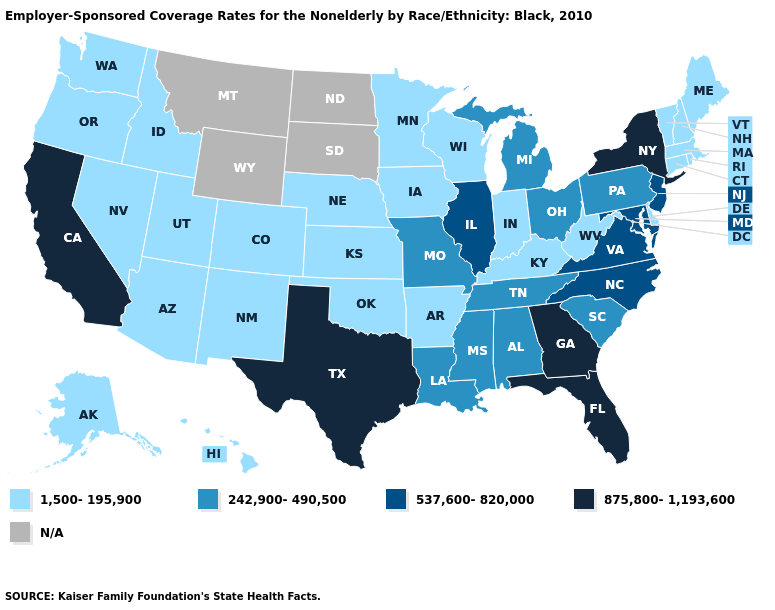Among the states that border Mississippi , which have the highest value?
Concise answer only. Alabama, Louisiana, Tennessee. What is the value of Wyoming?
Be succinct. N/A. Name the states that have a value in the range 242,900-490,500?
Give a very brief answer. Alabama, Louisiana, Michigan, Mississippi, Missouri, Ohio, Pennsylvania, South Carolina, Tennessee. Among the states that border Pennsylvania , does New Jersey have the highest value?
Keep it brief. No. Does the map have missing data?
Write a very short answer. Yes. What is the value of California?
Answer briefly. 875,800-1,193,600. Does the map have missing data?
Keep it brief. Yes. What is the value of Colorado?
Be succinct. 1,500-195,900. What is the highest value in the Northeast ?
Keep it brief. 875,800-1,193,600. What is the lowest value in states that border Kansas?
Be succinct. 1,500-195,900. Does the map have missing data?
Keep it brief. Yes. Which states have the lowest value in the MidWest?
Answer briefly. Indiana, Iowa, Kansas, Minnesota, Nebraska, Wisconsin. What is the value of California?
Answer briefly. 875,800-1,193,600. What is the highest value in the Northeast ?
Be succinct. 875,800-1,193,600. 